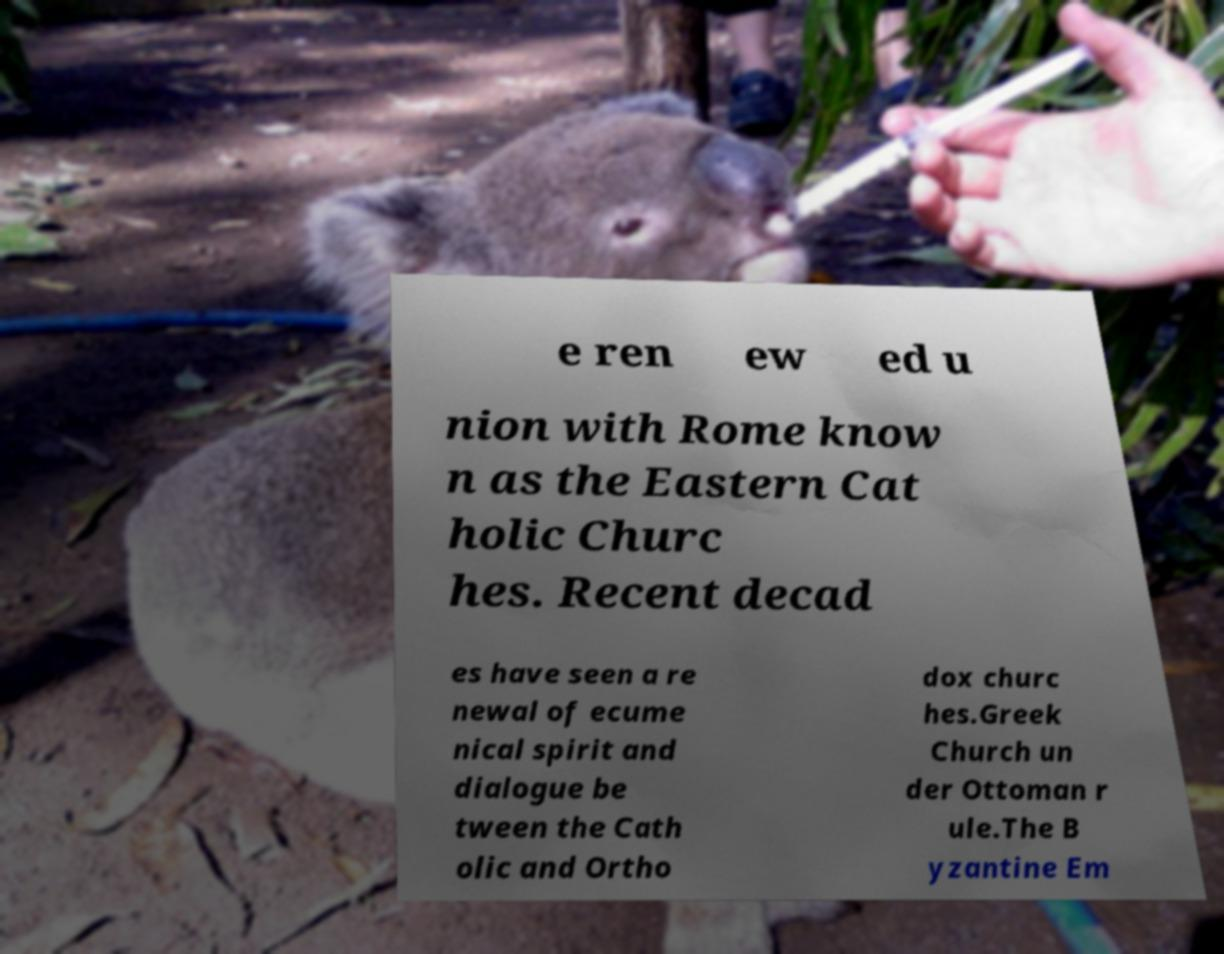Please identify and transcribe the text found in this image. e ren ew ed u nion with Rome know n as the Eastern Cat holic Churc hes. Recent decad es have seen a re newal of ecume nical spirit and dialogue be tween the Cath olic and Ortho dox churc hes.Greek Church un der Ottoman r ule.The B yzantine Em 